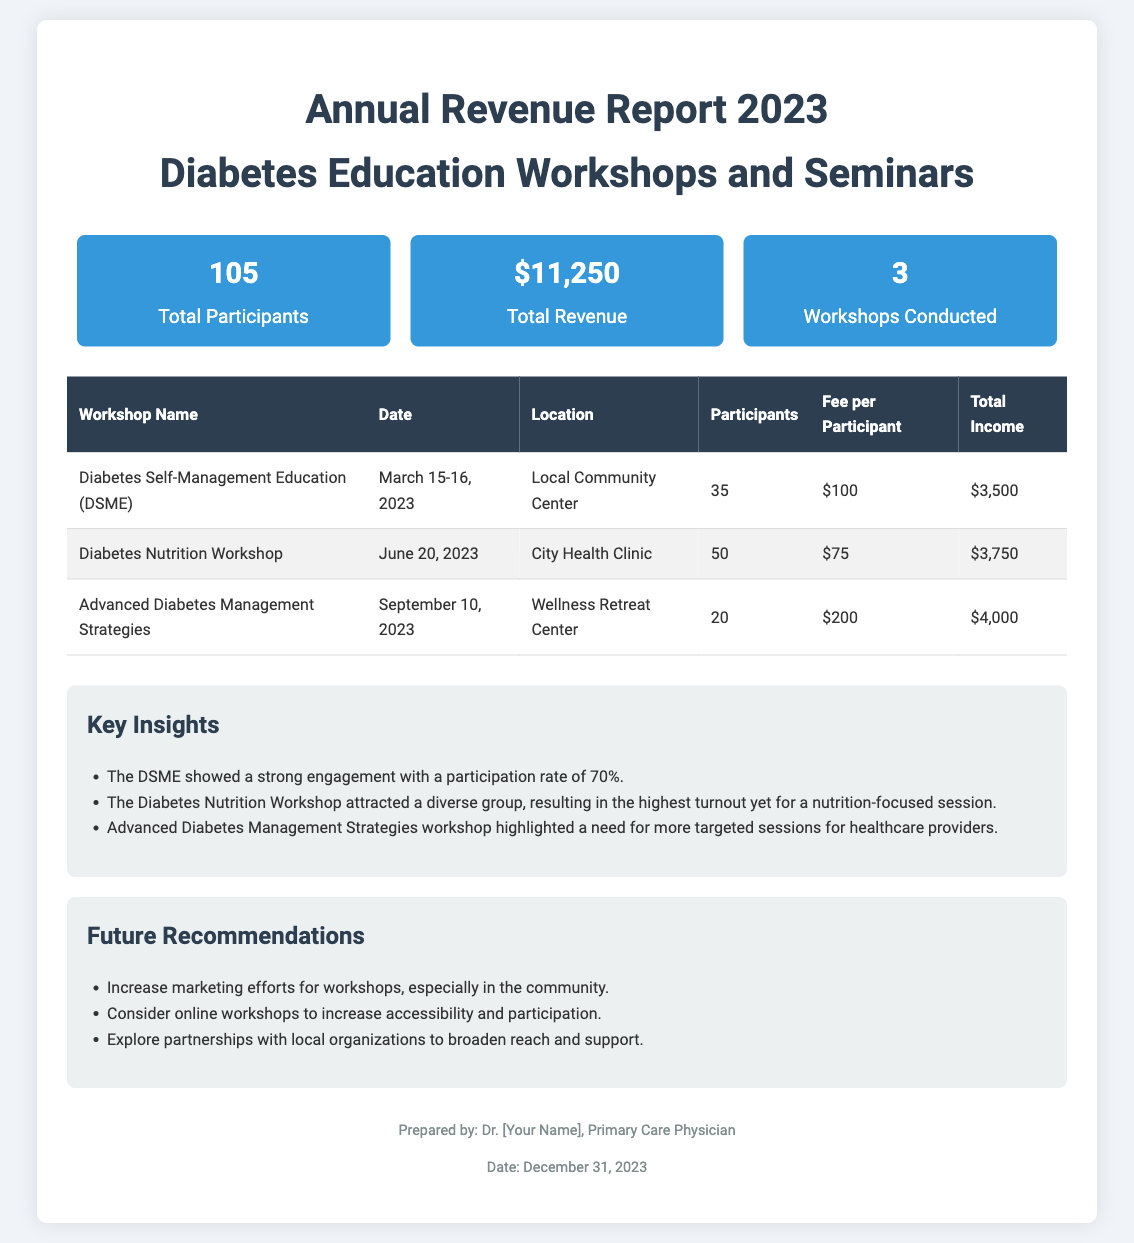What is the total number of participants? The total number of participants is directly stated in the summary section of the document.
Answer: 105 What was the revenue from the Diabetes Nutrition Workshop? The revenue from this specific workshop can be found in the table under "Total Income."
Answer: $3,750 What is the date of the Advanced Diabetes Management Strategies workshop? The date can be found in the table next to the workshop name.
Answer: September 10, 2023 How many workshops were conducted in total? The total number of workshops is indicated in the summary section.
Answer: 3 Which workshop had the highest fee per participant? This information requires comparison of the "Fee per Participant" column in the table.
Answer: Advanced Diabetes Management Strategies What is the total revenue generated from all workshops combined? The total revenue is the sum of the "Total Income" for each workshop as provided in the table.
Answer: $11,250 What is one key insight from the report? The report lists several insights in a dedicated section that summarizes findings.
Answer: The DSME showed a strong engagement with a participation rate of 70% What is a recommendation provided in the report? The recommendations are listed in a specific section aimed at improving future events.
Answer: Increase marketing efforts for workshops, especially in the community What is the location of the Diabetes Self-Management Education workshop? The location is specified in the table corresponding to the respective workshop.
Answer: Local Community Center 